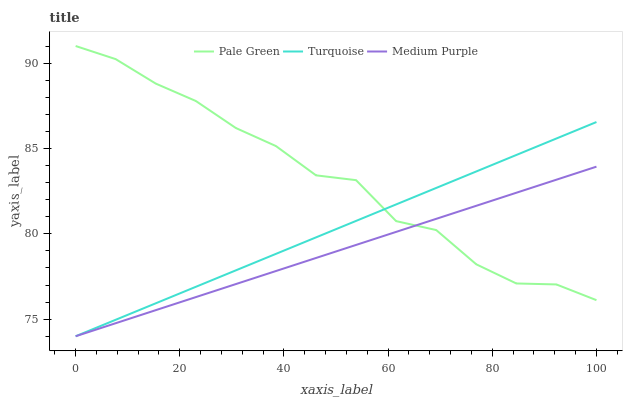Does Medium Purple have the minimum area under the curve?
Answer yes or no. Yes. Does Pale Green have the maximum area under the curve?
Answer yes or no. Yes. Does Turquoise have the minimum area under the curve?
Answer yes or no. No. Does Turquoise have the maximum area under the curve?
Answer yes or no. No. Is Medium Purple the smoothest?
Answer yes or no. Yes. Is Pale Green the roughest?
Answer yes or no. Yes. Is Turquoise the smoothest?
Answer yes or no. No. Is Turquoise the roughest?
Answer yes or no. No. Does Pale Green have the lowest value?
Answer yes or no. No. Does Pale Green have the highest value?
Answer yes or no. Yes. Does Turquoise have the highest value?
Answer yes or no. No. Does Turquoise intersect Medium Purple?
Answer yes or no. Yes. Is Turquoise less than Medium Purple?
Answer yes or no. No. Is Turquoise greater than Medium Purple?
Answer yes or no. No. 